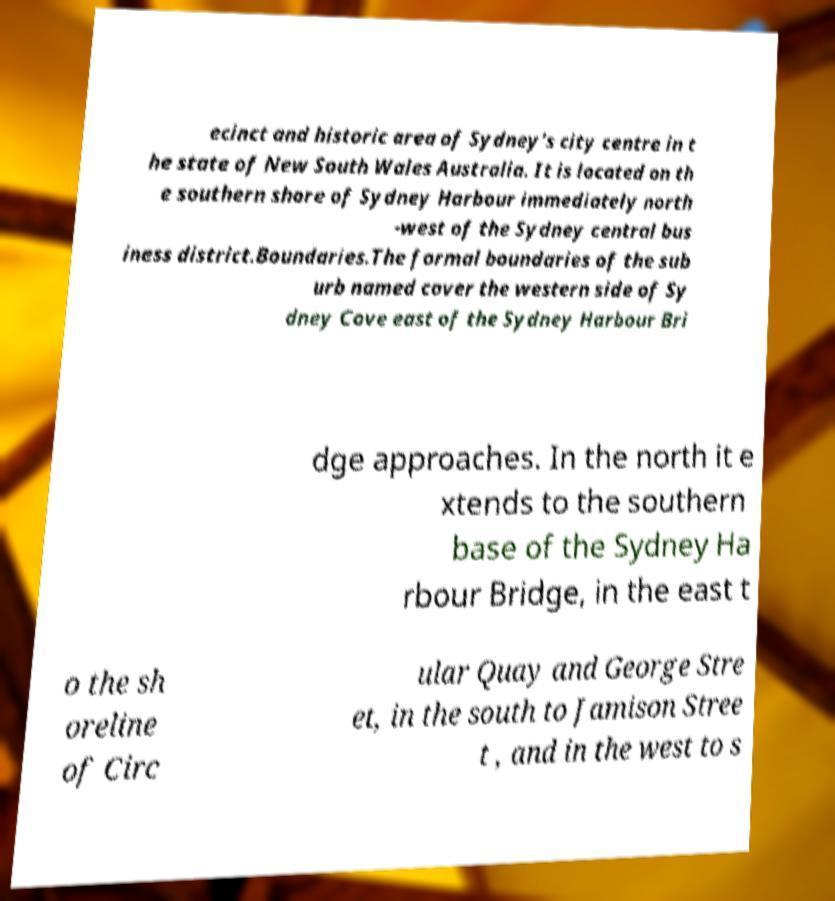Please read and relay the text visible in this image. What does it say? ecinct and historic area of Sydney's city centre in t he state of New South Wales Australia. It is located on th e southern shore of Sydney Harbour immediately north -west of the Sydney central bus iness district.Boundaries.The formal boundaries of the sub urb named cover the western side of Sy dney Cove east of the Sydney Harbour Bri dge approaches. In the north it e xtends to the southern base of the Sydney Ha rbour Bridge, in the east t o the sh oreline of Circ ular Quay and George Stre et, in the south to Jamison Stree t , and in the west to s 